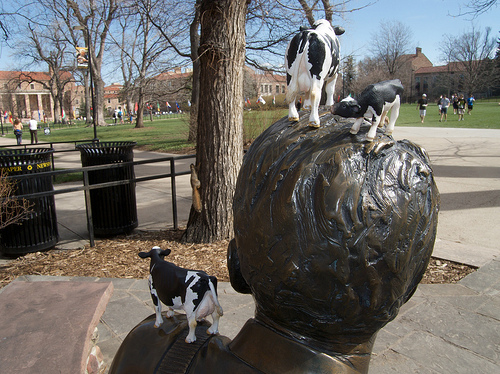<image>
Is there a statue under the cow? Yes. The statue is positioned underneath the cow, with the cow above it in the vertical space. Is the guy in front of the guy? Yes. The guy is positioned in front of the guy, appearing closer to the camera viewpoint. 